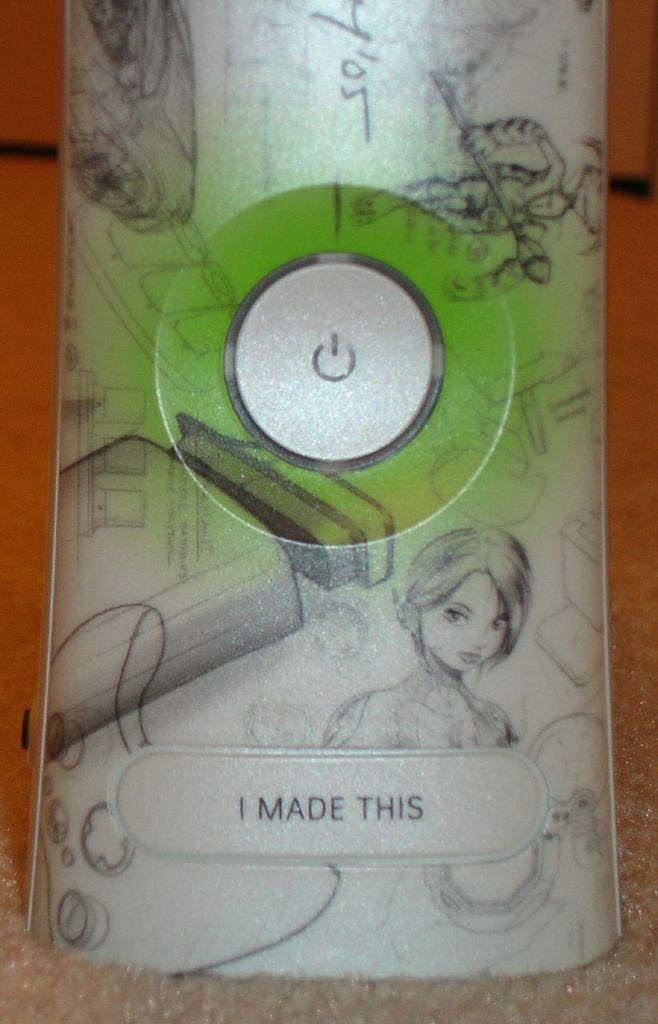What object can be seen in the image? There is a remote in the image. What feature does the remote have? The remote has a power button. How many hands are visible in the image? There are no hands visible in the image; it only shows a remote with a power button. 